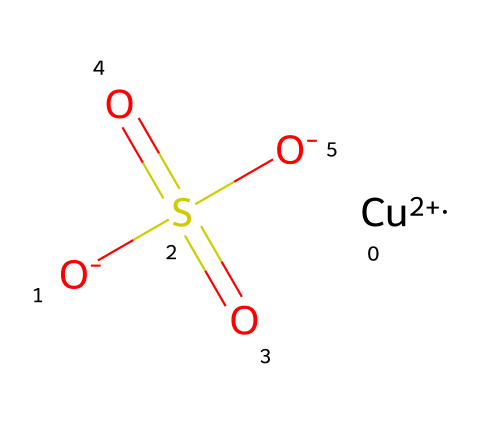How many oxygen atoms are present in copper sulfate? The SMILES representation indicates there are four oxygen atoms: two in the sulfate group (attached to sulfur) and two as separate charged ions.
Answer: four What is the central metal ion in this chemical? In the SMILES structure, the notation [Cu+2] indicates that copper (Cu) is the central metal ion with a +2 oxidation state.
Answer: copper What type of bond connects the sulfur and oxygen in the sulfate group? The chemical structure shows the sulfate part has the format S(=O)(=O) and two -O groups, indicating double bonds with two oxygens and single bonds with two others, resulting in covalent bonds.
Answer: covalent How does copper sulfate function in a garden? Copper sulfate acts as a fungicide by disrupting the cellular processes of fungi, which is reflected in its toxicological properties against plant pathogens.
Answer: fungicide What can be inferred about the charge of the sulfate group? The SMILES shows two negative charges linked to the sulfur, indicating that the sulfate ion carries a -2 charge overall.
Answer: -2 Is copper sulfate considered an organic or inorganic compound? The presence of a metal ion and a sulfate group categorically indicates that copper sulfate is an inorganic compound.
Answer: inorganic 